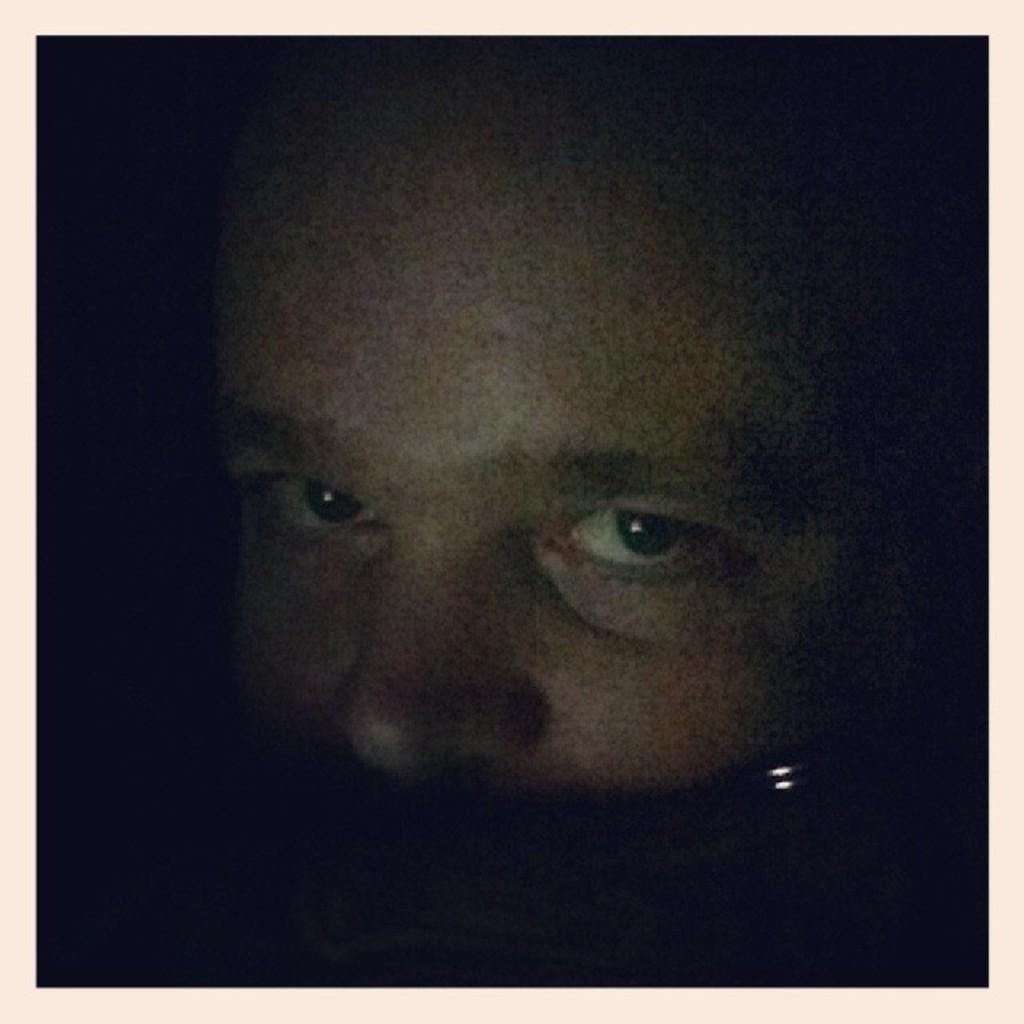In one or two sentences, can you explain what this image depicts? This is an edited image. I can see the face of a person. The background looks dark. 